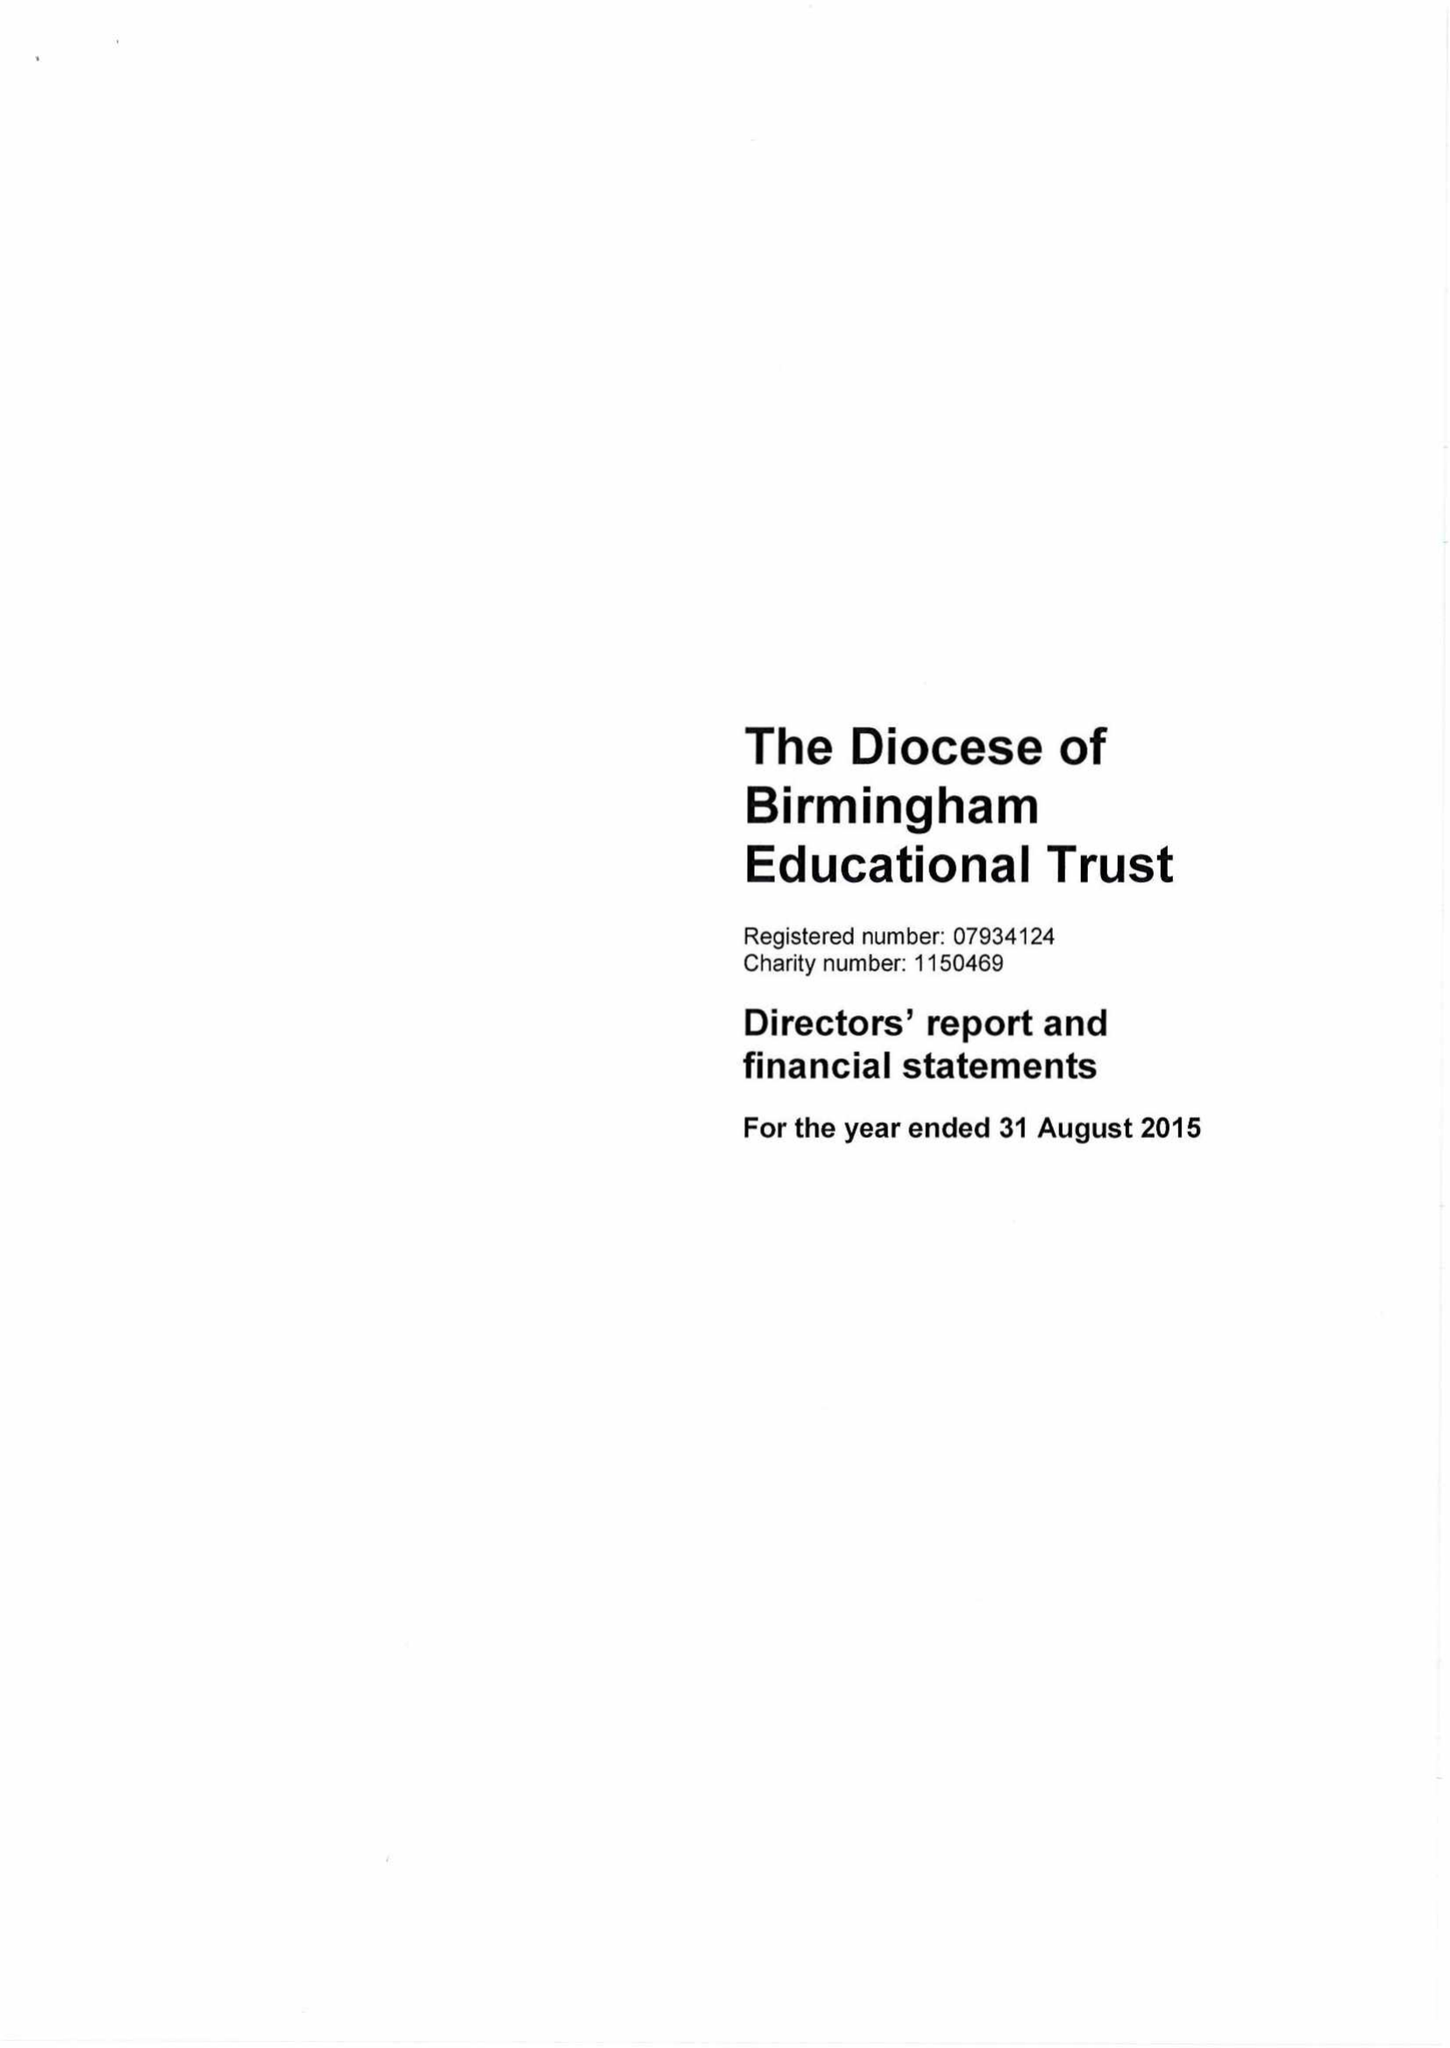What is the value for the spending_annually_in_british_pounds?
Answer the question using a single word or phrase. 209849.00 